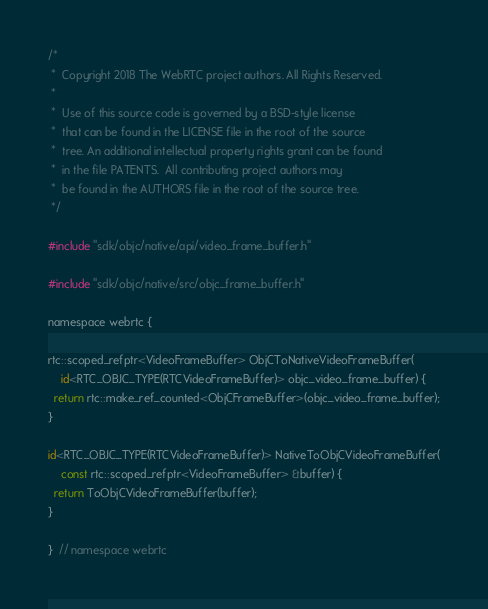Convert code to text. <code><loc_0><loc_0><loc_500><loc_500><_ObjectiveC_>/*
 *  Copyright 2018 The WebRTC project authors. All Rights Reserved.
 *
 *  Use of this source code is governed by a BSD-style license
 *  that can be found in the LICENSE file in the root of the source
 *  tree. An additional intellectual property rights grant can be found
 *  in the file PATENTS.  All contributing project authors may
 *  be found in the AUTHORS file in the root of the source tree.
 */

#include "sdk/objc/native/api/video_frame_buffer.h"

#include "sdk/objc/native/src/objc_frame_buffer.h"

namespace webrtc {

rtc::scoped_refptr<VideoFrameBuffer> ObjCToNativeVideoFrameBuffer(
    id<RTC_OBJC_TYPE(RTCVideoFrameBuffer)> objc_video_frame_buffer) {
  return rtc::make_ref_counted<ObjCFrameBuffer>(objc_video_frame_buffer);
}

id<RTC_OBJC_TYPE(RTCVideoFrameBuffer)> NativeToObjCVideoFrameBuffer(
    const rtc::scoped_refptr<VideoFrameBuffer> &buffer) {
  return ToObjCVideoFrameBuffer(buffer);
}

}  // namespace webrtc
</code> 